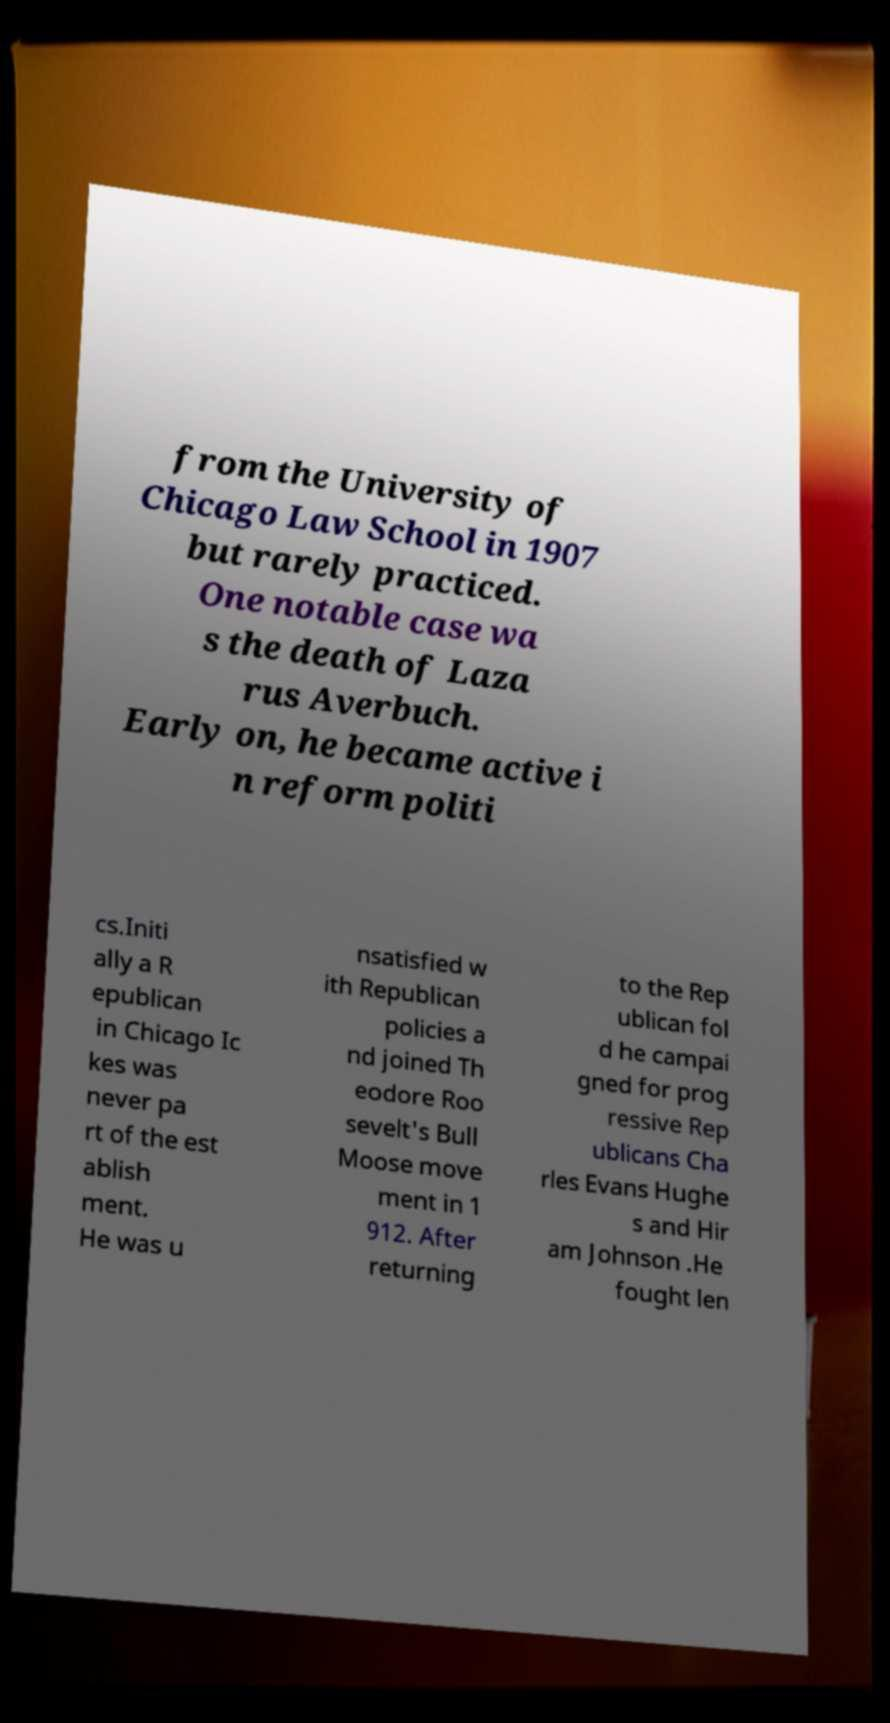I need the written content from this picture converted into text. Can you do that? from the University of Chicago Law School in 1907 but rarely practiced. One notable case wa s the death of Laza rus Averbuch. Early on, he became active i n reform politi cs.Initi ally a R epublican in Chicago Ic kes was never pa rt of the est ablish ment. He was u nsatisfied w ith Republican policies a nd joined Th eodore Roo sevelt's Bull Moose move ment in 1 912. After returning to the Rep ublican fol d he campai gned for prog ressive Rep ublicans Cha rles Evans Hughe s and Hir am Johnson .He fought len 